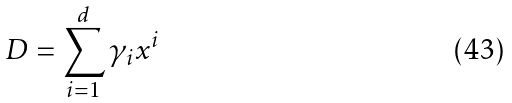<formula> <loc_0><loc_0><loc_500><loc_500>D = \sum _ { i = 1 } ^ { d } \gamma _ { i } x ^ { i }</formula> 